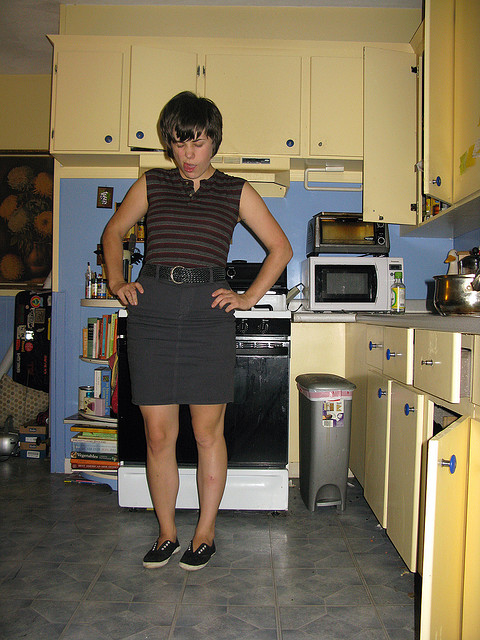What kind of decor style is seen in the kitchen? The kitchen features a retro decor style with vintage yellow cabinets, a simple tile backsplash, and an uncluttered, functional arrangement that suggests a mid-20th century American kitchen aesthetic. 